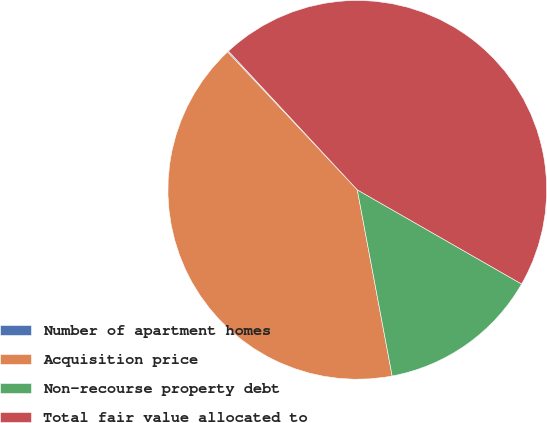Convert chart. <chart><loc_0><loc_0><loc_500><loc_500><pie_chart><fcel>Number of apartment homes<fcel>Acquisition price<fcel>Non-recourse property debt<fcel>Total fair value allocated to<nl><fcel>0.1%<fcel>40.93%<fcel>13.77%<fcel>45.19%<nl></chart> 